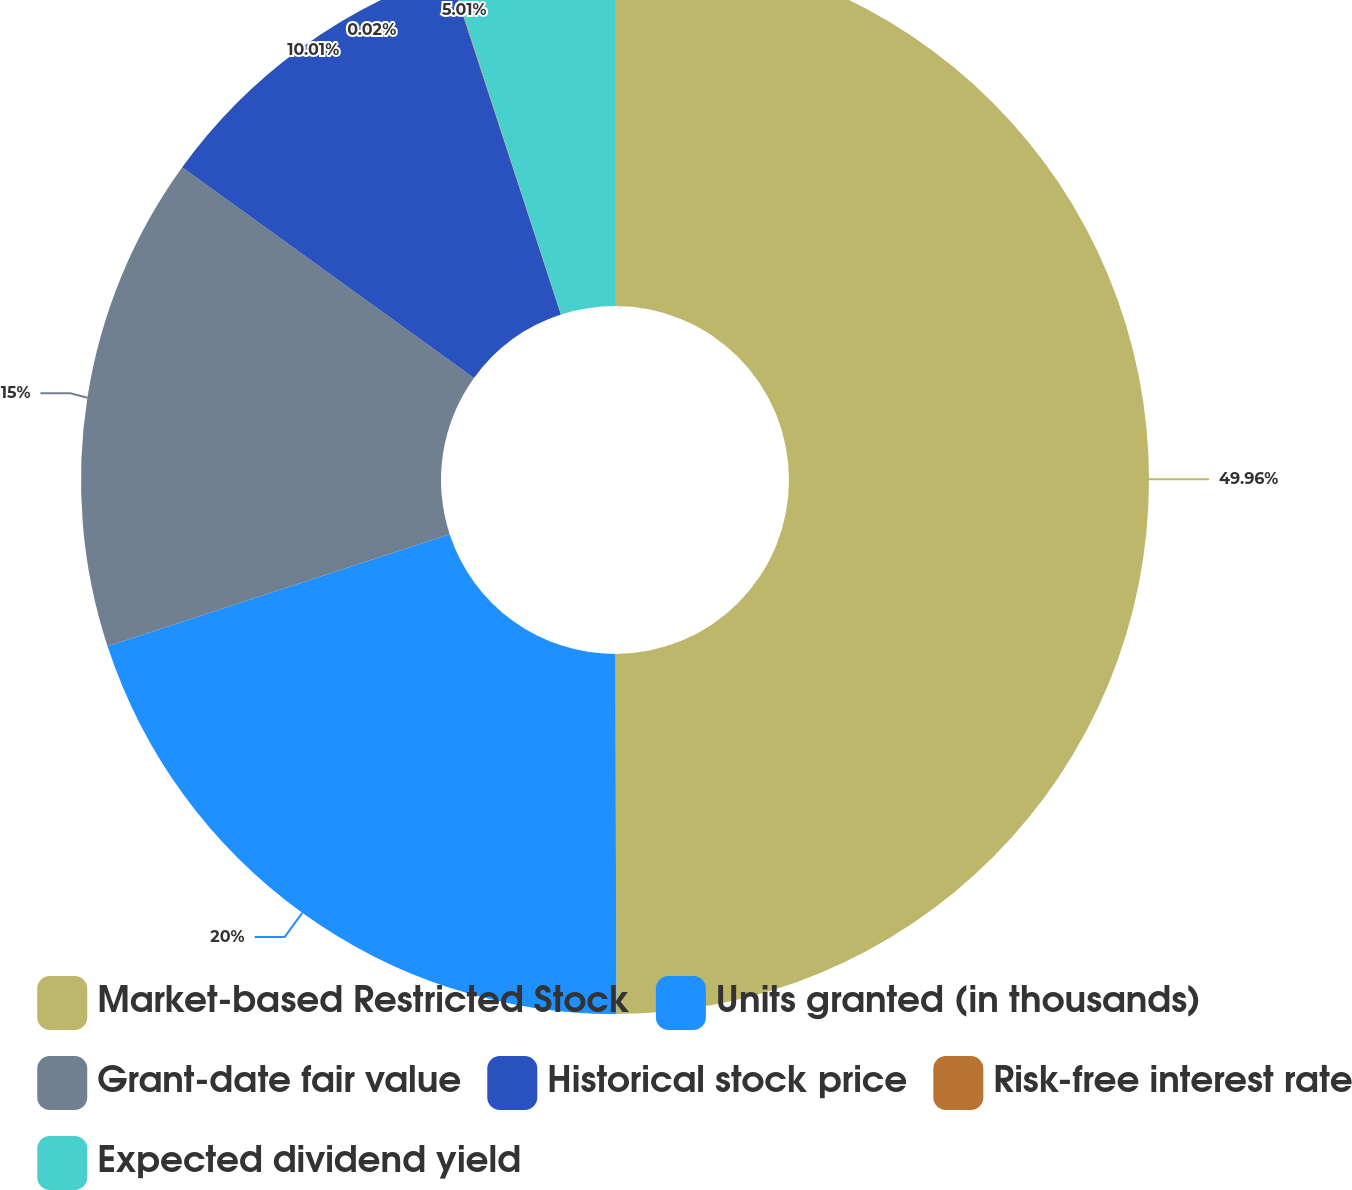Convert chart. <chart><loc_0><loc_0><loc_500><loc_500><pie_chart><fcel>Market-based Restricted Stock<fcel>Units granted (in thousands)<fcel>Grant-date fair value<fcel>Historical stock price<fcel>Risk-free interest rate<fcel>Expected dividend yield<nl><fcel>49.96%<fcel>20.0%<fcel>15.0%<fcel>10.01%<fcel>0.02%<fcel>5.01%<nl></chart> 